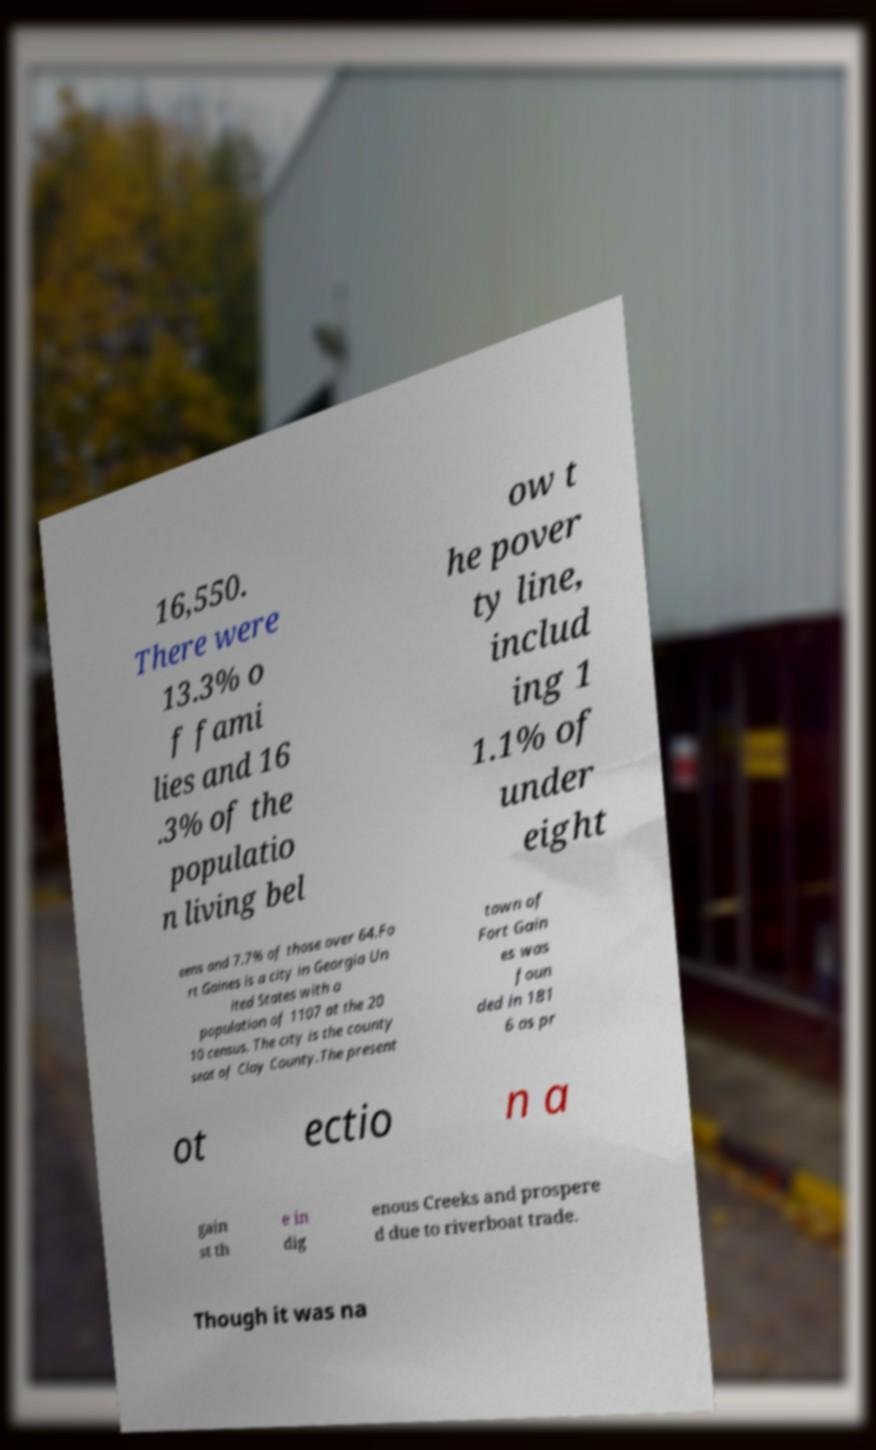Can you accurately transcribe the text from the provided image for me? 16,550. There were 13.3% o f fami lies and 16 .3% of the populatio n living bel ow t he pover ty line, includ ing 1 1.1% of under eight eens and 7.7% of those over 64.Fo rt Gaines is a city in Georgia Un ited States with a population of 1107 at the 20 10 census. The city is the county seat of Clay County.The present town of Fort Gain es was foun ded in 181 6 as pr ot ectio n a gain st th e in dig enous Creeks and prospere d due to riverboat trade. Though it was na 